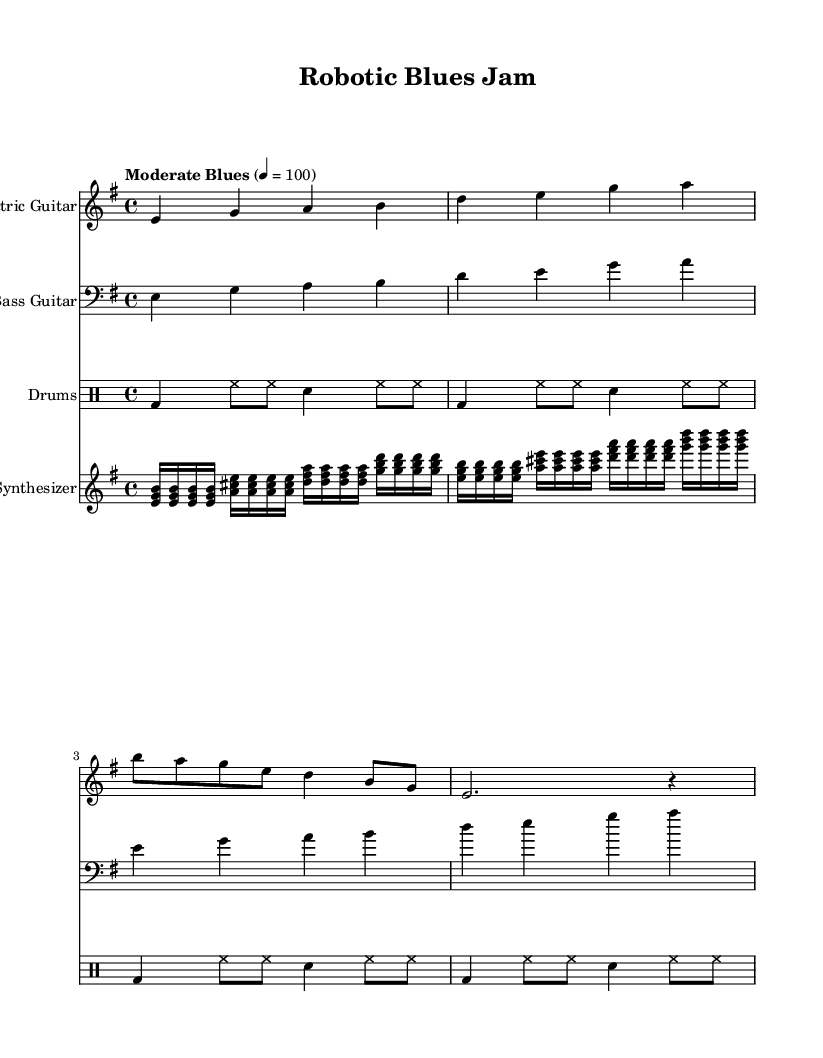What is the key signature of this music? The key signature can be found in the beginning of the music sheet, indicated by the symbol that shows which notes are sharp or flat. In this case, the key signature has one sharp which indicates it is in E minor.
Answer: E minor What is the time signature of this music? The time signature is located at the beginning of the music piece, right after the key signature. It is represented by two numbers, the upper number indicates the number of beats per measure, and the lower number indicates the note value that receives one beat. Here, it shows 4 over 4, meaning there are four beats in each measure.
Answer: 4/4 What is the tempo marking of this music? The tempo marking is found at the start of the piece, indicating the speed at which the music should be played. It is typically written above the staff. In this sheet music, it states "Moderate Blues" with a tempo of 100 BPM.
Answer: Moderate Blues, 100 How many measures are there in the electric guitar part? To determine the number of measures, count the sets of vertical lines that divide the staff into sections (measures). Each measure is separated by a vertical bar. In this electric guitar part, there are 8 measures counted.
Answer: 8 What type of musical elements does the synthesizer introduce to this electric blues piece? The synthesizer part introduces electronic and synthesized elements. It uses chords played in rapid succession, creating an electronic texture that complements the traditional blues instrumentation. This incorporation of synthesized sounds is characteristic of Electric Blues fusion.
Answer: Electronic and synthesized elements What is the rhythmic pattern of the drums in the first measure? The rhythm pattern of the drums can be identified by analyzing the notations for each beat in the first measure. The first measure contains a bass drum on the first beat, followed by hi-hat notes on the subsequent beats, and a snare on the third beat. This creates a standard rock drum pattern that is common in blues music.
Answer: Bass drum, hi-hat, snare 